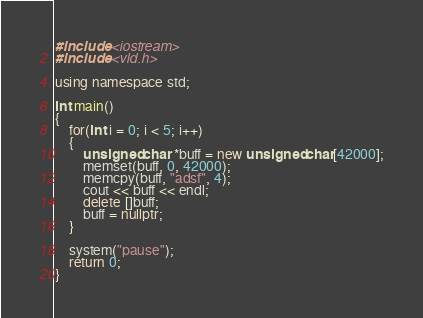Convert code to text. <code><loc_0><loc_0><loc_500><loc_500><_C++_>#include <iostream>
#include <vld.h>

using namespace std;

int main()
{
	for(int i = 0; i < 5; i++)
	{
		unsigned char *buff = new unsigned char[42000];
		memset(buff, 0, 42000);
		memcpy(buff, "adsf", 4);
		cout << buff << endl;
		delete []buff;
		buff = nullptr;
	}

	system("pause");
	return 0;
}</code> 